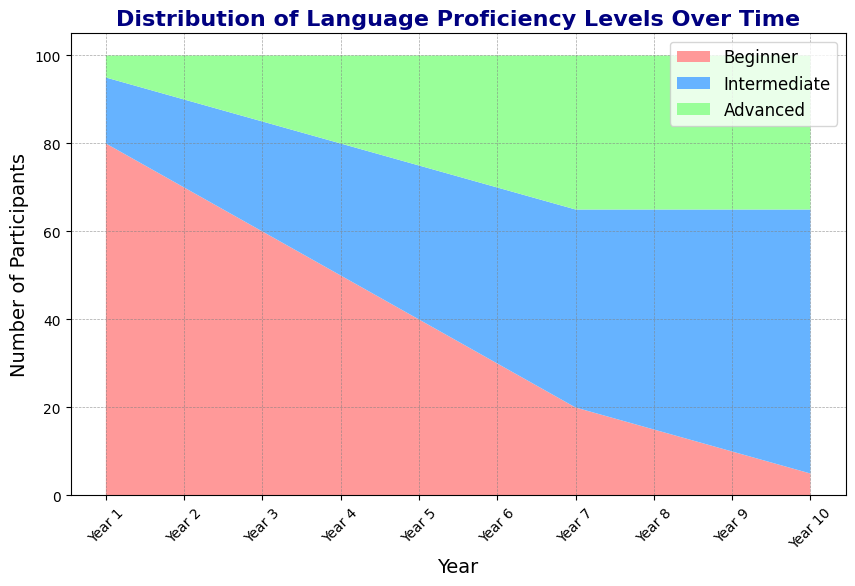What's the total number of participants in Year 5? To find the total number of participants in Year 5, sum the numbers of Beginner, Intermediate, and Advanced participants. 40 (Beginner) + 35 (Intermediate) + 25 (Advanced) = 100.
Answer: 100 Which proficiency level sees an increase in participants every year? Observe the plot and identify the trend lines for Beginner, Intermediate, and Advanced levels. The Intermediate and Advanced levels both show an increasing trend, but the Intermediate level sees a consistent yearly increase.
Answer: Intermediate How many participants moved from Beginner to Intermediate over ten years? The number of Beginner participants decreases from 80 to 5 over ten years, which is 80 - 5 = 75 participants. The number of Intermediate participants increases from 15 to 60, which is 60 - 15 = 45 participants. Only 45 of the 75 Beginner participants reached Intermediate.
Answer: 45 In which year do Advanced participants exceed Intermediate participants? Comparing the heights of the green (Intermediate) and blue (Advanced) areas on the plot, there is no year where the Advanced participants exceed the Intermediate participants.
Answer: Never What is the proportion of Advanced participants in Year 10? In Year 10, there are 5 Beginner, 60 Intermediate, and 35 Advanced participants. The total is 5 + 60 + 35 = 100 participants. The proportion of Advanced participants is 35 / 100 = 0.35.
Answer: 35% Which year had the highest number of Intermediate participants? By examining the plot, the tallest blue area for Intermediate participants is in Year 10, with 60 Intermediate participants.
Answer: Year 10 Compare the number of Beginner participants in Year 1 and Year 2. The Beginner participants in Year 1 are 80, and in Year 2 are 70. The difference is 80 - 70 = 10 fewer participants in Year 2.
Answer: 10 fewer How many years does it take for the number of Advanced participants to triple from Year 1? The number of Advanced participants in Year 1 is 5. To triple, it becomes 5 * 3 = 15. This number is reached in Year 3.
Answer: 3 years What color represents Beginner participants in the plot? The Beginner participants are represented by the color red.
Answer: Red 